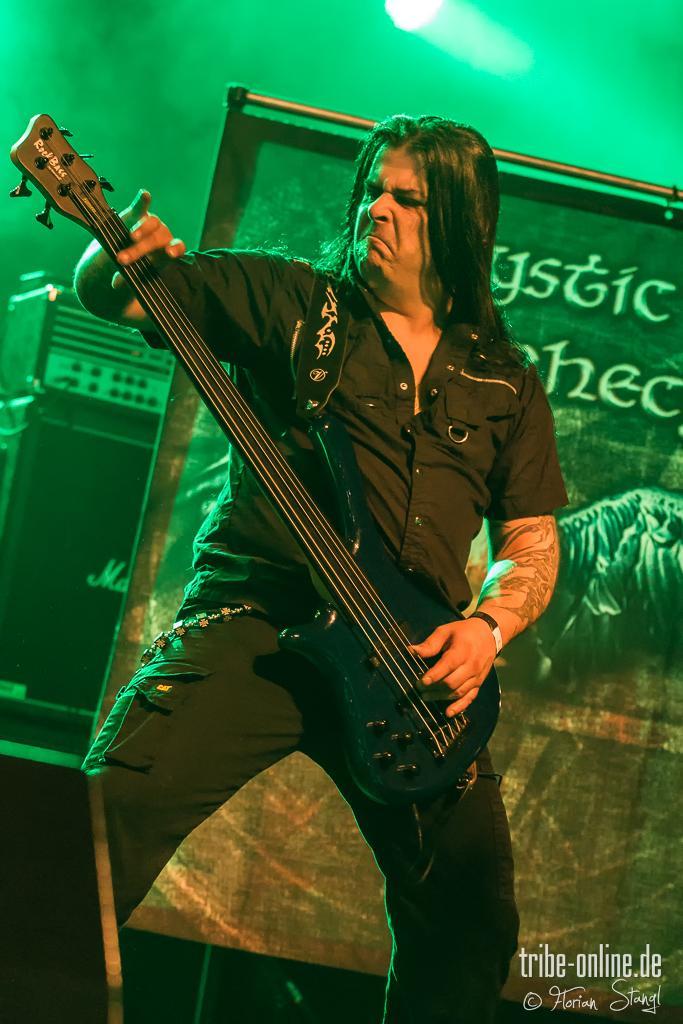Please provide a concise description of this image. In the center of the image there is a person holding a guitar. In the background of the image there is a banner. To the bottom of the image there is text. 